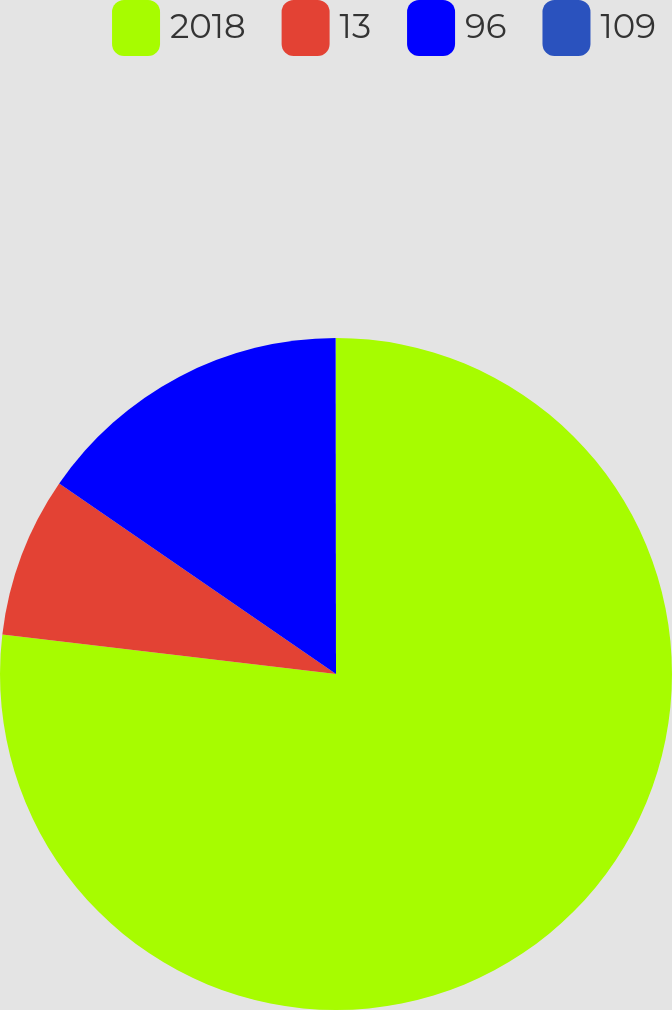Convert chart to OTSL. <chart><loc_0><loc_0><loc_500><loc_500><pie_chart><fcel>2018<fcel>13<fcel>96<fcel>109<nl><fcel>76.88%<fcel>7.71%<fcel>15.39%<fcel>0.02%<nl></chart> 